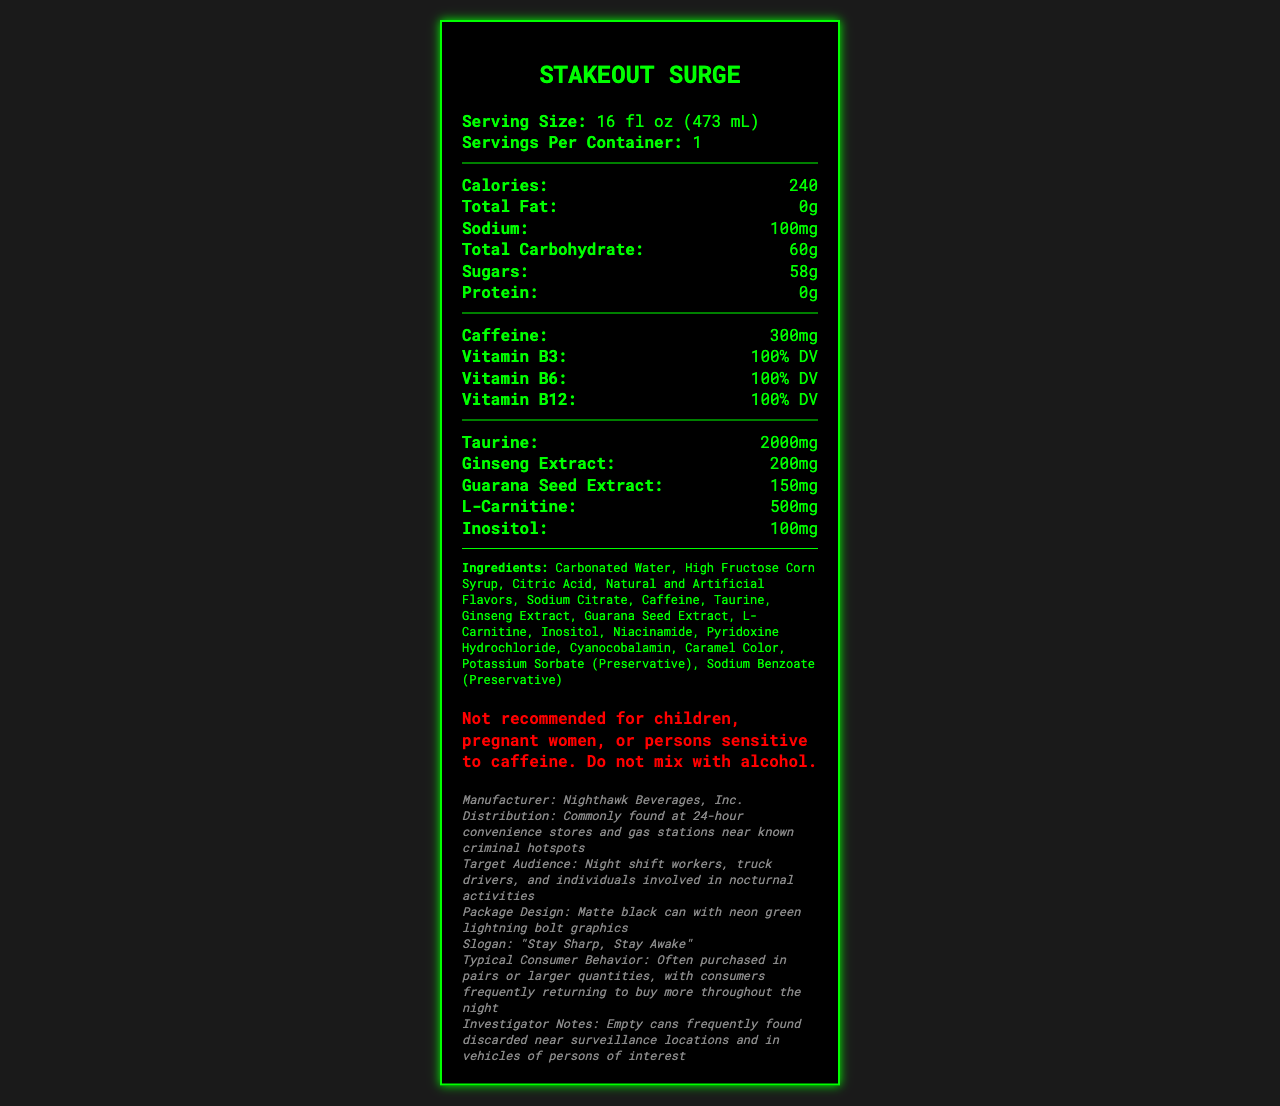what is the serving size of Stakeout Surge? The serving size is mentioned at the top of the document.
Answer: 16 fl oz (473 mL) how many calories does one serving contain? The document states that one serving of Stakeout Surge contains 240 calories.
Answer: 240 how much caffeine is found in the energy drink? The document clearly lists caffeine content as 300mg.
Answer: 300mg what is the amount of sugars in the drink? The document mentions the amount of sugars is 58g under the carbohydrate section.
Answer: 58g which vitamins are covered in the nutrition facts? The document lists the percentages of Vitamin B3, B6, and B12 under the nutrition facts.
Answer: Vitamin B3, Vitamin B6, Vitamin B12 who manufactures Stakeout Surge? The manufacturer is listed in the notes section at the bottom.
Answer: Nighthawk Beverages, Inc. where is this energy drink commonly found? The distribution information is detailed in the notes section.
Answer: 24-hour convenience stores and gas stations near known criminal hotspots who is the target audience for this drink? The target audience is mentioned in the notes section.
Answer: Night shift workers, truck drivers, and individuals involved in nocturnal activities what is the main ingredient listed for Stakeout Surge? The first ingredient in the ingredients list is Carbonated Water.
Answer: Carbonated Water what warning is provided on the label? The warning text is highlighted in red in the document.
Answer: Not recommended for children, pregnant women, or persons sensitive to caffeine. Do not mix with alcohol. which of the following is NOT an ingredient in Stakeout Surge? A. Taurine B. Sodium Citrate C. Inositol D. Vitamin C The detailed ingredient list in the document does not include Vitamin C.
Answer: D. Vitamin C how many servings are there per container? A. 1 B. 2 C. 3 D. 4 The document states there is 1 serving per container.
Answer: A. 1 how often are consumers likely to purchase this drink? A. Once a day B. Twice a day C. Frequently throughout the night D. Once a week The typical consumer behavior notes suggest that consumers frequently return to buy more throughout the night.
Answer: C. Frequently throughout the night is this energy drink suitable for pregnant women? The warning states that it is not recommended for pregnant women.
Answer: No summarize the main idea of the document. The label provides comprehensive information about the drink, including calories, vitamins, ingredients, and its target demographic.
Answer: The document is a Nutrition Facts Label for an energy drink called Stakeout Surge, detailing its nutritional content, target audience, warnings, and distribution channels. how does the taste of Stakeout Surge compare to similar energy drinks? The document does not provide any information regarding the taste of Stakeout Surge.
Answer: Not enough information 